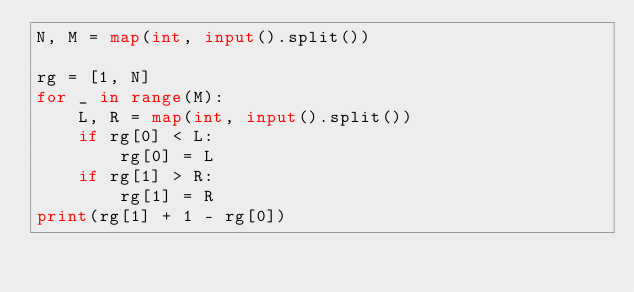<code> <loc_0><loc_0><loc_500><loc_500><_Python_>N, M = map(int, input().split())

rg = [1, N]
for _ in range(M):
    L, R = map(int, input().split())
    if rg[0] < L:
        rg[0] = L
    if rg[1] > R:
        rg[1] = R
print(rg[1] + 1 - rg[0])</code> 